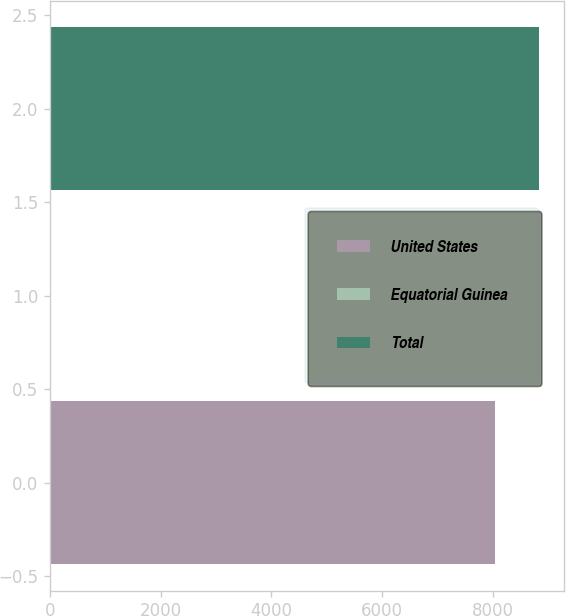<chart> <loc_0><loc_0><loc_500><loc_500><bar_chart><fcel>United States<fcel>Equatorial Guinea<fcel>Total<nl><fcel>8038<fcel>10<fcel>8842.1<nl></chart> 